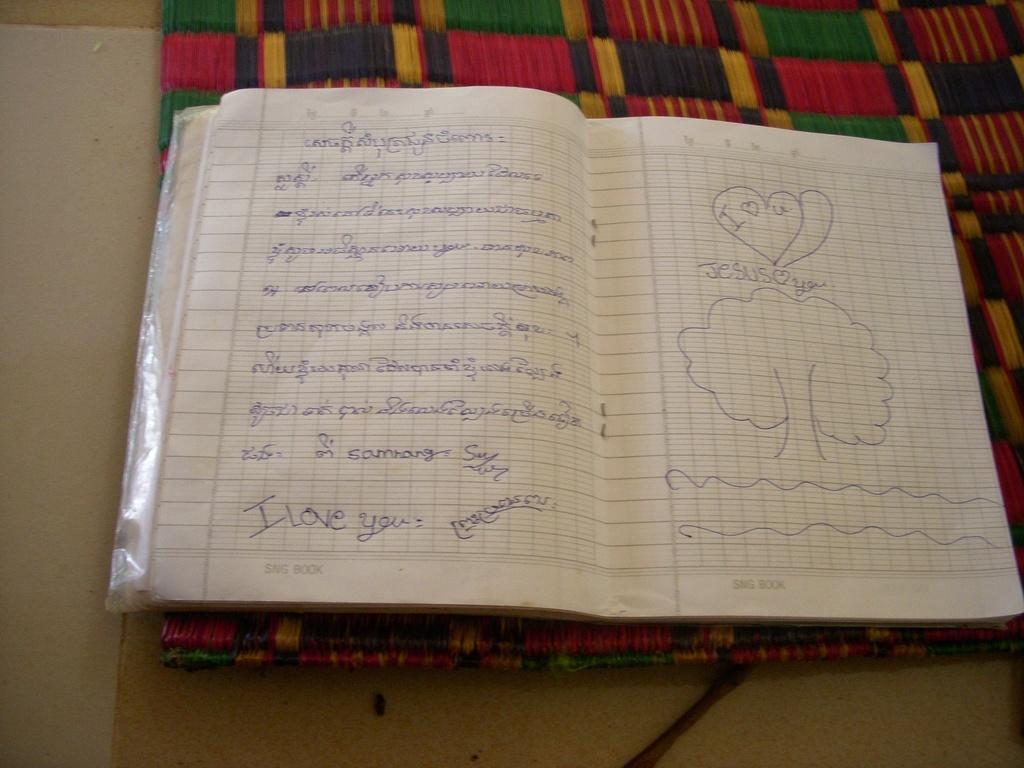What is written at the bottom of the page?
Ensure brevity in your answer.  I love you. 